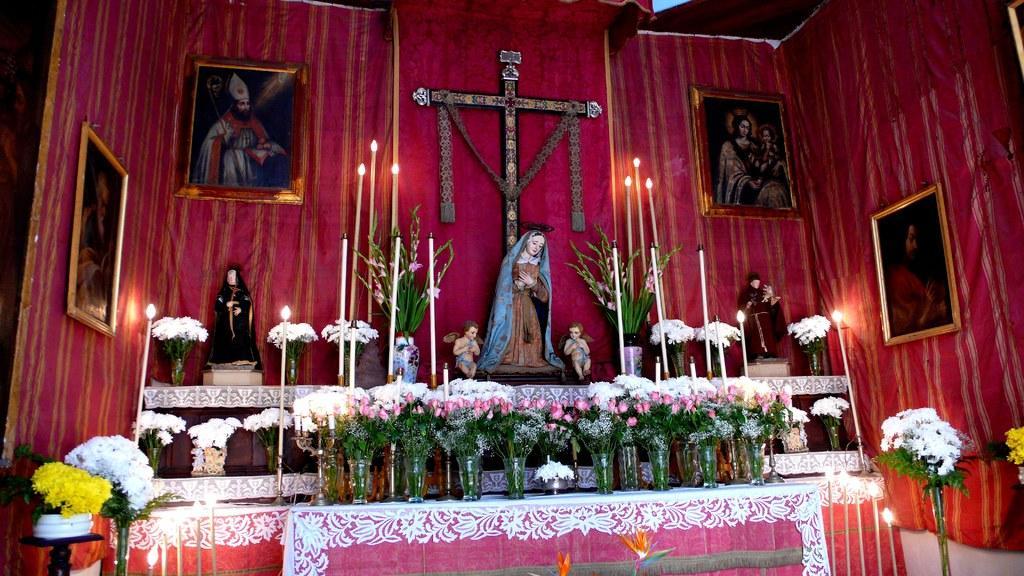Can you describe this image briefly? In this image I can see there are so many flower pots kept on the table and I can see a red color , on the wall I can see a photo frame attached to the wall and I can see a cross attached to the wall in the middle , and in front of the wall I can see sculptures and candles and flower pots visible. 